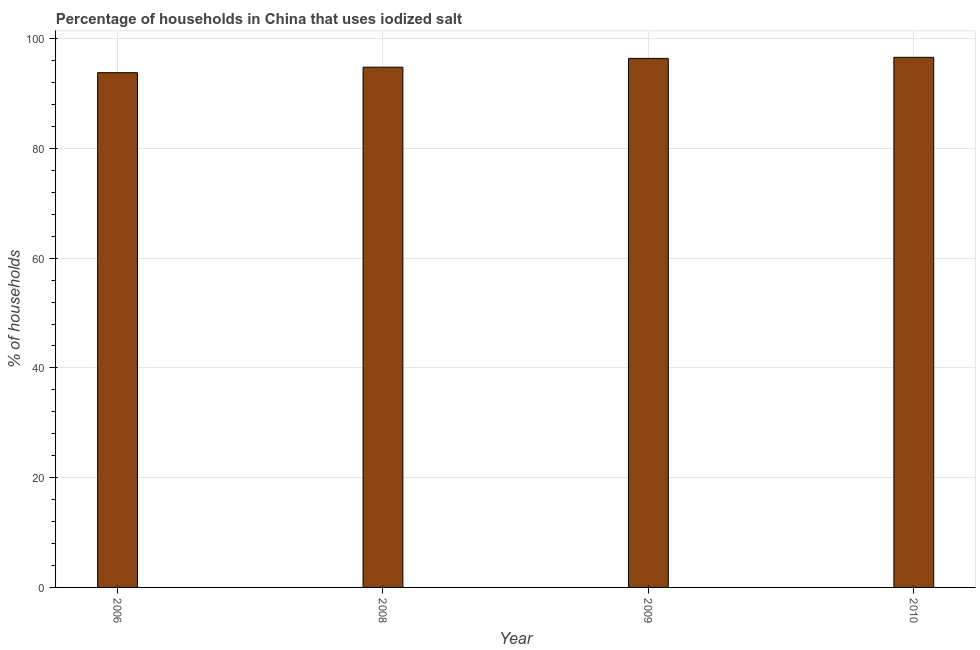Does the graph contain any zero values?
Your response must be concise. No. What is the title of the graph?
Offer a terse response. Percentage of households in China that uses iodized salt. What is the label or title of the Y-axis?
Provide a short and direct response. % of households. What is the percentage of households where iodized salt is consumed in 2010?
Provide a short and direct response. 96.6. Across all years, what is the maximum percentage of households where iodized salt is consumed?
Your answer should be compact. 96.6. Across all years, what is the minimum percentage of households where iodized salt is consumed?
Make the answer very short. 93.8. In which year was the percentage of households where iodized salt is consumed maximum?
Your response must be concise. 2010. In which year was the percentage of households where iodized salt is consumed minimum?
Make the answer very short. 2006. What is the sum of the percentage of households where iodized salt is consumed?
Provide a short and direct response. 381.6. What is the difference between the percentage of households where iodized salt is consumed in 2009 and 2010?
Your answer should be very brief. -0.2. What is the average percentage of households where iodized salt is consumed per year?
Provide a short and direct response. 95.4. What is the median percentage of households where iodized salt is consumed?
Make the answer very short. 95.6. In how many years, is the percentage of households where iodized salt is consumed greater than 64 %?
Offer a very short reply. 4. What is the difference between the highest and the second highest percentage of households where iodized salt is consumed?
Your answer should be compact. 0.2. What is the difference between the highest and the lowest percentage of households where iodized salt is consumed?
Provide a succinct answer. 2.8. How many bars are there?
Make the answer very short. 4. How many years are there in the graph?
Ensure brevity in your answer.  4. What is the % of households of 2006?
Provide a short and direct response. 93.8. What is the % of households of 2008?
Offer a very short reply. 94.8. What is the % of households in 2009?
Provide a succinct answer. 96.4. What is the % of households in 2010?
Offer a very short reply. 96.6. What is the difference between the % of households in 2006 and 2009?
Your answer should be very brief. -2.6. What is the difference between the % of households in 2006 and 2010?
Ensure brevity in your answer.  -2.8. What is the difference between the % of households in 2008 and 2009?
Keep it short and to the point. -1.6. What is the difference between the % of households in 2008 and 2010?
Your response must be concise. -1.8. What is the ratio of the % of households in 2006 to that in 2009?
Ensure brevity in your answer.  0.97. What is the ratio of the % of households in 2006 to that in 2010?
Your answer should be compact. 0.97. What is the ratio of the % of households in 2008 to that in 2010?
Offer a terse response. 0.98. 